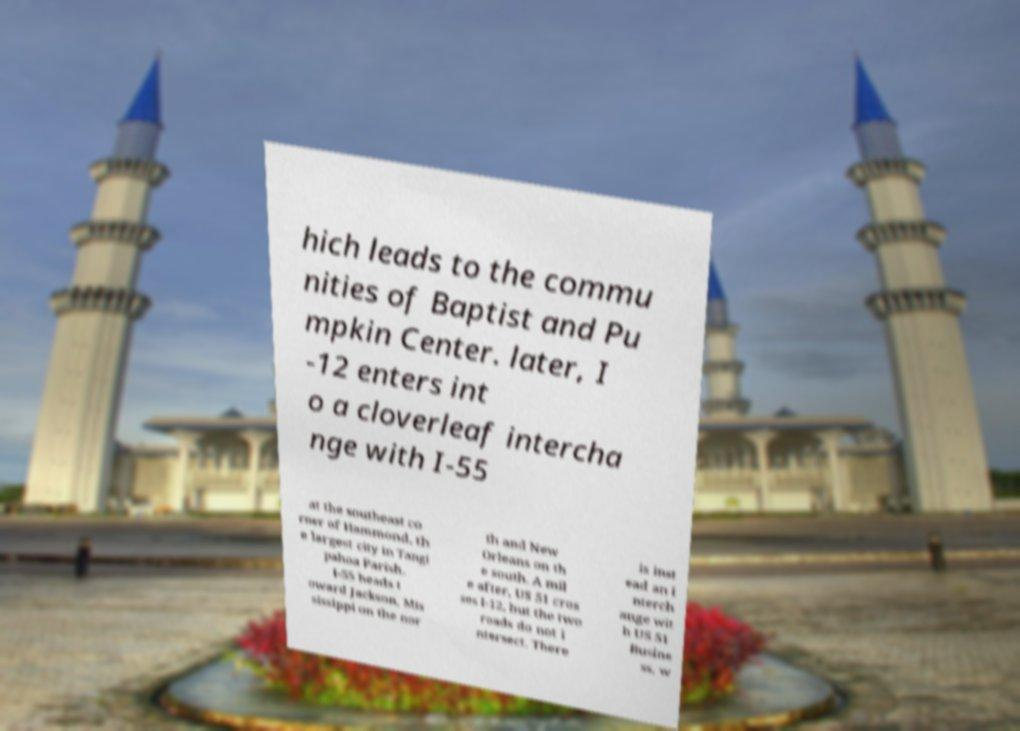Please identify and transcribe the text found in this image. hich leads to the commu nities of Baptist and Pu mpkin Center. later, I -12 enters int o a cloverleaf intercha nge with I-55 at the southeast co rner of Hammond, th e largest city in Tangi pahoa Parish. I-55 heads t oward Jackson, Mis sissippi on the nor th and New Orleans on th e south. A mil e after, US 51 cros ses I-12, but the two roads do not i ntersect. There is inst ead an i nterch ange wit h US 51 Busine ss, w 